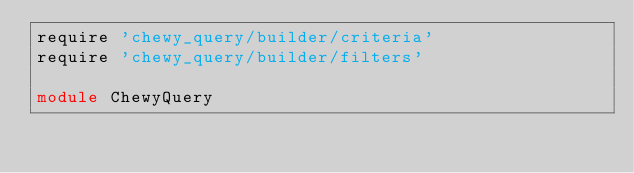Convert code to text. <code><loc_0><loc_0><loc_500><loc_500><_Ruby_>require 'chewy_query/builder/criteria'
require 'chewy_query/builder/filters'

module ChewyQuery</code> 